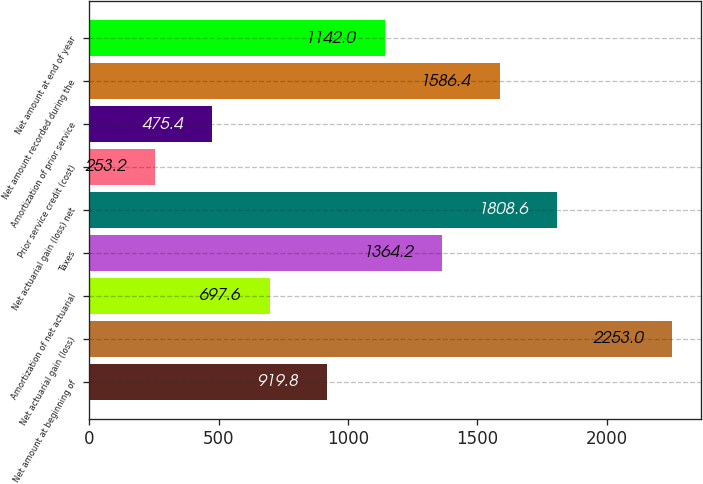Convert chart to OTSL. <chart><loc_0><loc_0><loc_500><loc_500><bar_chart><fcel>Net amount at beginning of<fcel>Net actuarial gain (loss)<fcel>Amortization of net actuarial<fcel>Taxes<fcel>Net actuarial gain (loss) net<fcel>Prior service credit (cost)<fcel>Amortization of prior service<fcel>Net amount recorded during the<fcel>Net amount at end of year<nl><fcel>919.8<fcel>2253<fcel>697.6<fcel>1364.2<fcel>1808.6<fcel>253.2<fcel>475.4<fcel>1586.4<fcel>1142<nl></chart> 